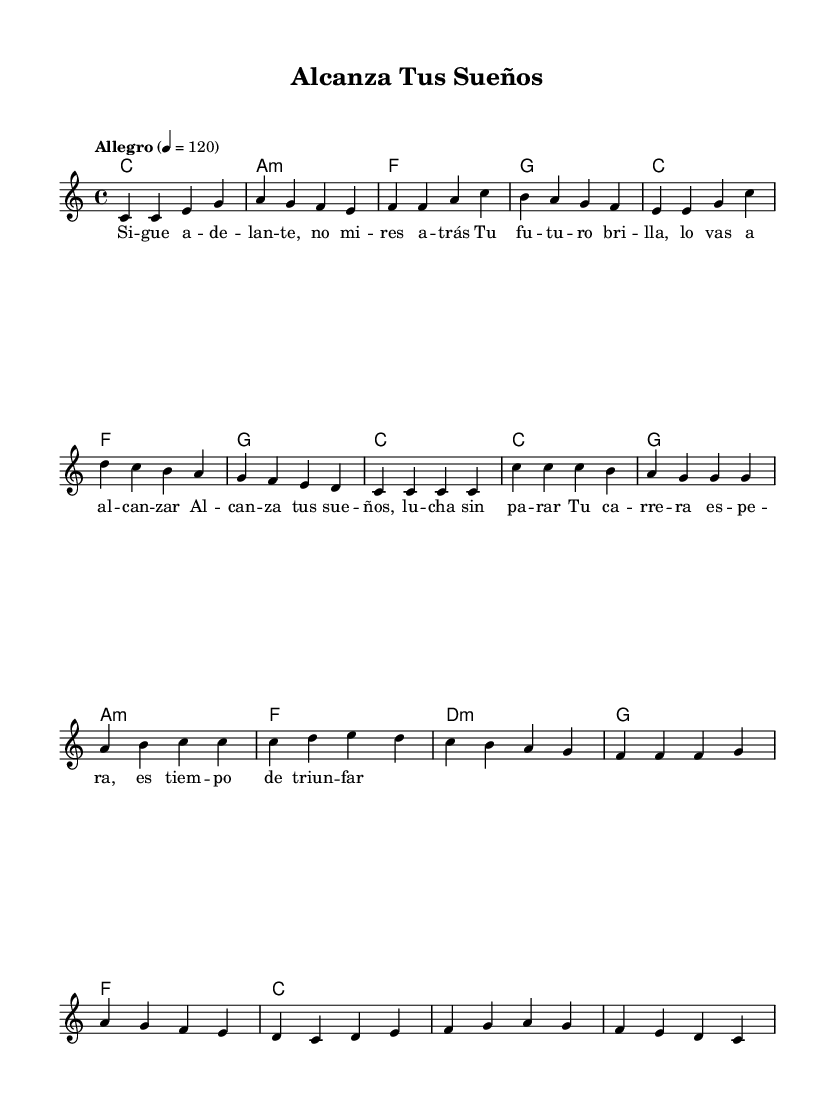What is the key signature of this music? The key signature is indicated by the absence of sharps or flats before the staff. This corresponds to C major.
Answer: C major What is the time signature of the piece? The time signature is displayed as a fraction indicating beats per measure, which here is shown as 4/4. This means there are four beats in each measure, and the quarter note gets one beat.
Answer: 4/4 What is the tempo marking and its BPM? The tempo marking is presented as "Allegro" followed by a number (4 = 120), which indicates the speed of the music; in this case, it is set to 120 beats per minute.
Answer: Allegro 120 How many measures are there in the verse section? By counting the distinct groupings of notes and rests in the verse section, which is notated separately from the chorus, we can determine there are eight measures.
Answer: 8 What type of harmony is used in the first measure of the verse? The first measure indicates a chord with the root note C, which is recognized as a major chord based on the context of the chord naming convention used in this piece.
Answer: C major What is the main theme conveyed in the lyrics? The lyrics reveal a motivational theme focusing on perseverance and achievement, as they encourage the listener to pursue dreams and fight without surrender. The prominent phrases reinforce a call to action and positivity.
Answer: Motivational In what format is the song structured? The structure primarily alternates between the verse and the chorus sections, a common format in Latin pop music, which typically allows for emotional buildup followed by a catchy and memorable chorus.
Answer: Verse-Chorus 